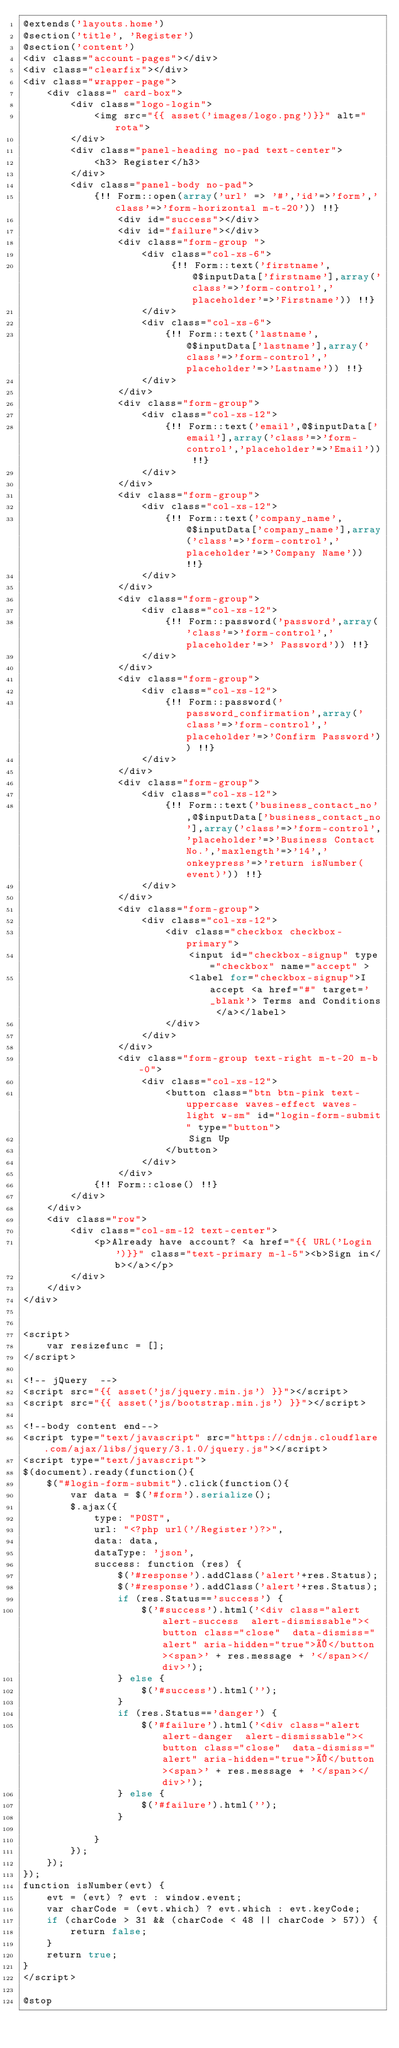<code> <loc_0><loc_0><loc_500><loc_500><_PHP_>@extends('layouts.home')
@section('title', 'Register')
@section('content')
<div class="account-pages"></div>
<div class="clearfix"></div>
<div class="wrapper-page">
	<div class=" card-box">
		<div class="logo-login">
			<img src="{{ asset('images/logo.png')}}" alt="rota">  
		</div>
		<div class="panel-heading no-pad text-center"> 
			<h3> Register</h3>
		</div> 
		<div class="panel-body no-pad">
		    {!! Form::open(array('url' => '#','id'=>'form','class'=>'form-horizontal m-t-20')) !!}
				<div id="success"></div>
				<div id="failure"></div>
				<div class="form-group ">
					<div class="col-xs-6">
						 {!! Form::text('firstname',@$inputData['firstname'],array('class'=>'form-control','placeholder'=>'Firstname')) !!}
					</div>
					<div class="col-xs-6">
						{!! Form::text('lastname',@$inputData['lastname'],array('class'=>'form-control','placeholder'=>'Lastname')) !!}
					</div>
				</div>
				<div class="form-group">
					<div class="col-xs-12">
						{!! Form::text('email',@$inputData['email'],array('class'=>'form-control','placeholder'=>'Email')) !!}
					</div>
				</div>
				<div class="form-group">
					<div class="col-xs-12">
						{!! Form::text('company_name',@$inputData['company_name'],array('class'=>'form-control','placeholder'=>'Company Name')) !!}
					</div>
				</div>
				<div class="form-group">
					<div class="col-xs-12">
						{!! Form::password('password',array('class'=>'form-control','placeholder'=>' Password')) !!}
					</div>
				</div>
				<div class="form-group">
					<div class="col-xs-12">
						{!! Form::password('password_confirmation',array('class'=>'form-control','placeholder'=>'Confirm Password')) !!}
					</div>
				</div>
				<div class="form-group">
					<div class="col-xs-12">
						{!! Form::text('business_contact_no',@$inputData['business_contact_no'],array('class'=>'form-control','placeholder'=>'Business Contact No.','maxlength'=>'14','onkeypress'=>'return isNumber(event)')) !!}
					</div>
				</div>
				<div class="form-group">
					<div class="col-xs-12">
						<div class="checkbox checkbox-primary">
							<input id="checkbox-signup" type="checkbox" name="accept" >
							<label for="checkbox-signup">I accept <a href="#" target='_blank'> Terms and Conditions </a></label>
						</div>
					</div>
				</div>
				<div class="form-group text-right m-t-20 m-b-0">
					<div class="col-xs-12">
						<button class="btn btn-pink text-uppercase waves-effect waves-light w-sm" id="login-form-submit" type="button">
							Sign Up
						</button>
					</div>
				</div>	
			{!! Form::close() !!}
		</div>   
	</div>                              
	<div class="row">
		<div class="col-sm-12 text-center">
			<p>Already have account? <a href="{{ URL('Login')}}" class="text-primary m-l-5"><b>Sign in</b></a></p>	
		</div>
	</div>
</div>

	
<script>
	var resizefunc = [];
</script>

<!-- jQuery  -->
<script src="{{ asset('js/jquery.min.js') }}"></script>
<script src="{{ asset('js/bootstrap.min.js') }}"></script> 

<!--body content end-->
<script type="text/javascript" src="https://cdnjs.cloudflare.com/ajax/libs/jquery/3.1.0/jquery.js"></script>
<script type="text/javascript">
$(document).ready(function(){
	$("#login-form-submit").click(function(){
		var data = $('#form').serialize();
		$.ajax({
			type: "POST",
			url: "<?php url('/Register')?>",
			data: data,
			dataType: 'json',
			success: function (res) {
				$('#response').addClass('alert'+res.Status);
				$('#response').addClass('alert'+res.Status);
				if (res.Status=='success') {
					$('#success').html('<div class="alert alert-success  alert-dismissable"><button class="close"  data-dismiss="alert" aria-hidden="true">×</button><span>' + res.message + '</span></div>');
				} else {
					$('#success').html('');
				}
				if (res.Status=='danger') {
					$('#failure').html('<div class="alert alert-danger  alert-dismissable"><button class="close"  data-dismiss="alert" aria-hidden="true">×</button><span>' + res.message + '</span></div>');
				} else {
					$('#failure').html('');
				}
				
			}
        });
	});
});
function isNumber(evt) {
	evt = (evt) ? evt : window.event;
	var charCode = (evt.which) ? evt.which : evt.keyCode;
	if (charCode > 31 && (charCode < 48 || charCode > 57)) {
		return false;
	}
	return true;
}
</script>

@stop
</code> 